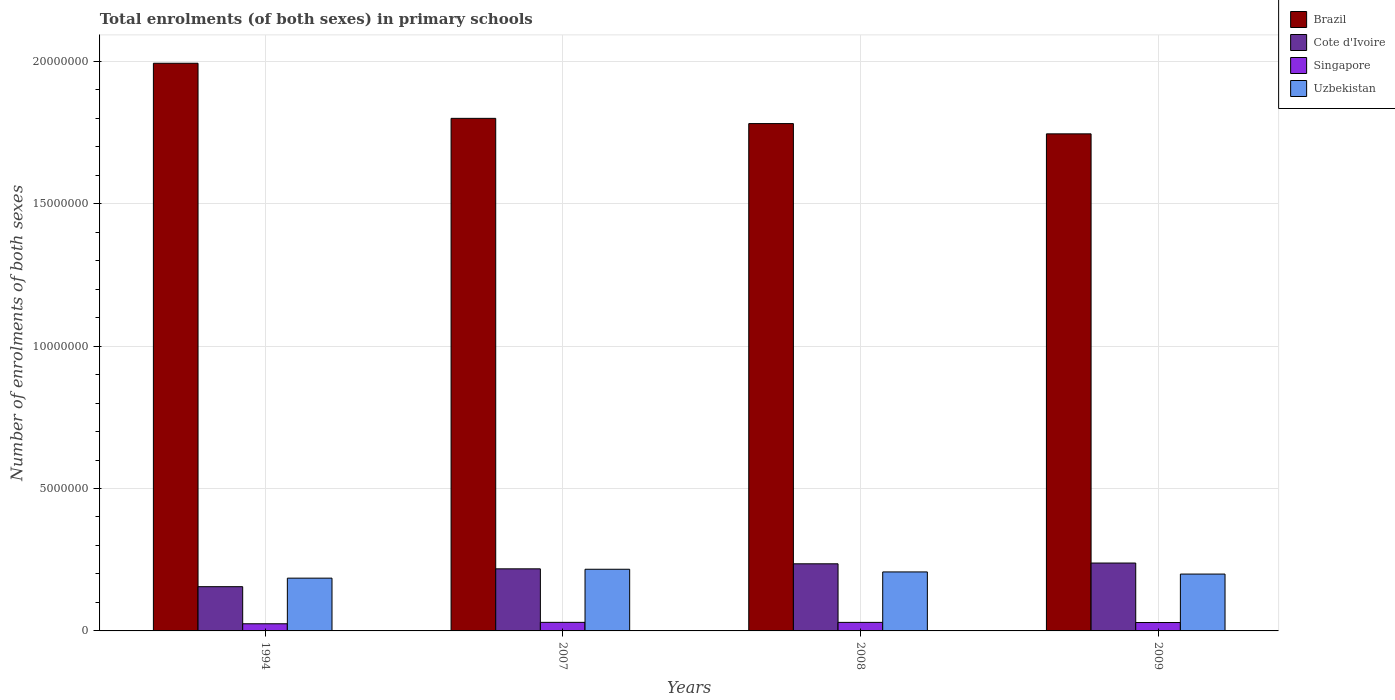How many bars are there on the 3rd tick from the right?
Ensure brevity in your answer.  4. What is the label of the 2nd group of bars from the left?
Your answer should be compact. 2007. What is the number of enrolments in primary schools in Uzbekistan in 1994?
Ensure brevity in your answer.  1.85e+06. Across all years, what is the maximum number of enrolments in primary schools in Uzbekistan?
Provide a short and direct response. 2.16e+06. Across all years, what is the minimum number of enrolments in primary schools in Uzbekistan?
Your answer should be very brief. 1.85e+06. In which year was the number of enrolments in primary schools in Uzbekistan minimum?
Your answer should be very brief. 1994. What is the total number of enrolments in primary schools in Uzbekistan in the graph?
Keep it short and to the point. 8.08e+06. What is the difference between the number of enrolments in primary schools in Cote d'Ivoire in 2008 and that in 2009?
Offer a terse response. -2.71e+04. What is the difference between the number of enrolments in primary schools in Brazil in 2009 and the number of enrolments in primary schools in Singapore in 1994?
Offer a terse response. 1.72e+07. What is the average number of enrolments in primary schools in Cote d'Ivoire per year?
Your response must be concise. 2.12e+06. In the year 2009, what is the difference between the number of enrolments in primary schools in Brazil and number of enrolments in primary schools in Singapore?
Your response must be concise. 1.72e+07. What is the ratio of the number of enrolments in primary schools in Uzbekistan in 2007 to that in 2009?
Your response must be concise. 1.08. What is the difference between the highest and the second highest number of enrolments in primary schools in Singapore?
Keep it short and to the point. 1397. What is the difference between the highest and the lowest number of enrolments in primary schools in Singapore?
Make the answer very short. 5.00e+04. In how many years, is the number of enrolments in primary schools in Cote d'Ivoire greater than the average number of enrolments in primary schools in Cote d'Ivoire taken over all years?
Your answer should be very brief. 3. What does the 2nd bar from the left in 2009 represents?
Give a very brief answer. Cote d'Ivoire. What does the 3rd bar from the right in 2007 represents?
Make the answer very short. Cote d'Ivoire. Are all the bars in the graph horizontal?
Offer a terse response. No. Does the graph contain any zero values?
Your response must be concise. No. What is the title of the graph?
Offer a very short reply. Total enrolments (of both sexes) in primary schools. What is the label or title of the Y-axis?
Give a very brief answer. Number of enrolments of both sexes. What is the Number of enrolments of both sexes in Brazil in 1994?
Give a very brief answer. 1.99e+07. What is the Number of enrolments of both sexes of Cote d'Ivoire in 1994?
Your response must be concise. 1.55e+06. What is the Number of enrolments of both sexes in Singapore in 1994?
Ensure brevity in your answer.  2.51e+05. What is the Number of enrolments of both sexes of Uzbekistan in 1994?
Make the answer very short. 1.85e+06. What is the Number of enrolments of both sexes of Brazil in 2007?
Your response must be concise. 1.80e+07. What is the Number of enrolments of both sexes of Cote d'Ivoire in 2007?
Provide a short and direct response. 2.18e+06. What is the Number of enrolments of both sexes of Singapore in 2007?
Keep it short and to the point. 3.01e+05. What is the Number of enrolments of both sexes in Uzbekistan in 2007?
Provide a succinct answer. 2.16e+06. What is the Number of enrolments of both sexes of Brazil in 2008?
Give a very brief answer. 1.78e+07. What is the Number of enrolments of both sexes of Cote d'Ivoire in 2008?
Your answer should be very brief. 2.36e+06. What is the Number of enrolments of both sexes of Singapore in 2008?
Keep it short and to the point. 3.00e+05. What is the Number of enrolments of both sexes in Uzbekistan in 2008?
Your response must be concise. 2.07e+06. What is the Number of enrolments of both sexes in Brazil in 2009?
Provide a succinct answer. 1.75e+07. What is the Number of enrolments of both sexes of Cote d'Ivoire in 2009?
Provide a short and direct response. 2.38e+06. What is the Number of enrolments of both sexes in Singapore in 2009?
Offer a very short reply. 2.95e+05. What is the Number of enrolments of both sexes of Uzbekistan in 2009?
Keep it short and to the point. 2.00e+06. Across all years, what is the maximum Number of enrolments of both sexes in Brazil?
Offer a terse response. 1.99e+07. Across all years, what is the maximum Number of enrolments of both sexes in Cote d'Ivoire?
Provide a succinct answer. 2.38e+06. Across all years, what is the maximum Number of enrolments of both sexes in Singapore?
Offer a very short reply. 3.01e+05. Across all years, what is the maximum Number of enrolments of both sexes of Uzbekistan?
Offer a terse response. 2.16e+06. Across all years, what is the minimum Number of enrolments of both sexes of Brazil?
Offer a very short reply. 1.75e+07. Across all years, what is the minimum Number of enrolments of both sexes of Cote d'Ivoire?
Provide a short and direct response. 1.55e+06. Across all years, what is the minimum Number of enrolments of both sexes of Singapore?
Keep it short and to the point. 2.51e+05. Across all years, what is the minimum Number of enrolments of both sexes in Uzbekistan?
Your response must be concise. 1.85e+06. What is the total Number of enrolments of both sexes in Brazil in the graph?
Offer a very short reply. 7.32e+07. What is the total Number of enrolments of both sexes in Cote d'Ivoire in the graph?
Provide a succinct answer. 8.47e+06. What is the total Number of enrolments of both sexes of Singapore in the graph?
Your answer should be compact. 1.15e+06. What is the total Number of enrolments of both sexes in Uzbekistan in the graph?
Offer a terse response. 8.08e+06. What is the difference between the Number of enrolments of both sexes of Brazil in 1994 and that in 2007?
Your answer should be compact. 1.93e+06. What is the difference between the Number of enrolments of both sexes of Cote d'Ivoire in 1994 and that in 2007?
Offer a very short reply. -6.26e+05. What is the difference between the Number of enrolments of both sexes of Singapore in 1994 and that in 2007?
Provide a succinct answer. -5.00e+04. What is the difference between the Number of enrolments of both sexes in Uzbekistan in 1994 and that in 2007?
Make the answer very short. -3.12e+05. What is the difference between the Number of enrolments of both sexes in Brazil in 1994 and that in 2008?
Your answer should be compact. 2.12e+06. What is the difference between the Number of enrolments of both sexes of Cote d'Ivoire in 1994 and that in 2008?
Offer a terse response. -8.03e+05. What is the difference between the Number of enrolments of both sexes of Singapore in 1994 and that in 2008?
Offer a terse response. -4.86e+04. What is the difference between the Number of enrolments of both sexes in Uzbekistan in 1994 and that in 2008?
Give a very brief answer. -2.18e+05. What is the difference between the Number of enrolments of both sexes in Brazil in 1994 and that in 2009?
Your answer should be very brief. 2.48e+06. What is the difference between the Number of enrolments of both sexes in Cote d'Ivoire in 1994 and that in 2009?
Make the answer very short. -8.30e+05. What is the difference between the Number of enrolments of both sexes of Singapore in 1994 and that in 2009?
Make the answer very short. -4.35e+04. What is the difference between the Number of enrolments of both sexes in Uzbekistan in 1994 and that in 2009?
Give a very brief answer. -1.43e+05. What is the difference between the Number of enrolments of both sexes in Brazil in 2007 and that in 2008?
Make the answer very short. 1.84e+05. What is the difference between the Number of enrolments of both sexes in Cote d'Ivoire in 2007 and that in 2008?
Your answer should be compact. -1.76e+05. What is the difference between the Number of enrolments of both sexes of Singapore in 2007 and that in 2008?
Your response must be concise. 1397. What is the difference between the Number of enrolments of both sexes of Uzbekistan in 2007 and that in 2008?
Offer a terse response. 9.36e+04. What is the difference between the Number of enrolments of both sexes of Brazil in 2007 and that in 2009?
Provide a short and direct response. 5.44e+05. What is the difference between the Number of enrolments of both sexes of Cote d'Ivoire in 2007 and that in 2009?
Make the answer very short. -2.04e+05. What is the difference between the Number of enrolments of both sexes in Singapore in 2007 and that in 2009?
Offer a terse response. 6499. What is the difference between the Number of enrolments of both sexes in Uzbekistan in 2007 and that in 2009?
Your answer should be compact. 1.69e+05. What is the difference between the Number of enrolments of both sexes of Brazil in 2008 and that in 2009?
Your answer should be compact. 3.61e+05. What is the difference between the Number of enrolments of both sexes in Cote d'Ivoire in 2008 and that in 2009?
Your response must be concise. -2.71e+04. What is the difference between the Number of enrolments of both sexes in Singapore in 2008 and that in 2009?
Provide a succinct answer. 5102. What is the difference between the Number of enrolments of both sexes in Uzbekistan in 2008 and that in 2009?
Keep it short and to the point. 7.56e+04. What is the difference between the Number of enrolments of both sexes of Brazil in 1994 and the Number of enrolments of both sexes of Cote d'Ivoire in 2007?
Provide a short and direct response. 1.78e+07. What is the difference between the Number of enrolments of both sexes in Brazil in 1994 and the Number of enrolments of both sexes in Singapore in 2007?
Your answer should be very brief. 1.96e+07. What is the difference between the Number of enrolments of both sexes of Brazil in 1994 and the Number of enrolments of both sexes of Uzbekistan in 2007?
Make the answer very short. 1.78e+07. What is the difference between the Number of enrolments of both sexes of Cote d'Ivoire in 1994 and the Number of enrolments of both sexes of Singapore in 2007?
Your answer should be compact. 1.25e+06. What is the difference between the Number of enrolments of both sexes of Cote d'Ivoire in 1994 and the Number of enrolments of both sexes of Uzbekistan in 2007?
Your answer should be compact. -6.11e+05. What is the difference between the Number of enrolments of both sexes of Singapore in 1994 and the Number of enrolments of both sexes of Uzbekistan in 2007?
Offer a terse response. -1.91e+06. What is the difference between the Number of enrolments of both sexes in Brazil in 1994 and the Number of enrolments of both sexes in Cote d'Ivoire in 2008?
Ensure brevity in your answer.  1.76e+07. What is the difference between the Number of enrolments of both sexes of Brazil in 1994 and the Number of enrolments of both sexes of Singapore in 2008?
Offer a very short reply. 1.96e+07. What is the difference between the Number of enrolments of both sexes in Brazil in 1994 and the Number of enrolments of both sexes in Uzbekistan in 2008?
Offer a terse response. 1.79e+07. What is the difference between the Number of enrolments of both sexes of Cote d'Ivoire in 1994 and the Number of enrolments of both sexes of Singapore in 2008?
Your answer should be compact. 1.25e+06. What is the difference between the Number of enrolments of both sexes of Cote d'Ivoire in 1994 and the Number of enrolments of both sexes of Uzbekistan in 2008?
Keep it short and to the point. -5.18e+05. What is the difference between the Number of enrolments of both sexes in Singapore in 1994 and the Number of enrolments of both sexes in Uzbekistan in 2008?
Give a very brief answer. -1.82e+06. What is the difference between the Number of enrolments of both sexes of Brazil in 1994 and the Number of enrolments of both sexes of Cote d'Ivoire in 2009?
Offer a terse response. 1.75e+07. What is the difference between the Number of enrolments of both sexes in Brazil in 1994 and the Number of enrolments of both sexes in Singapore in 2009?
Offer a very short reply. 1.96e+07. What is the difference between the Number of enrolments of both sexes in Brazil in 1994 and the Number of enrolments of both sexes in Uzbekistan in 2009?
Provide a succinct answer. 1.79e+07. What is the difference between the Number of enrolments of both sexes in Cote d'Ivoire in 1994 and the Number of enrolments of both sexes in Singapore in 2009?
Give a very brief answer. 1.26e+06. What is the difference between the Number of enrolments of both sexes in Cote d'Ivoire in 1994 and the Number of enrolments of both sexes in Uzbekistan in 2009?
Offer a terse response. -4.42e+05. What is the difference between the Number of enrolments of both sexes in Singapore in 1994 and the Number of enrolments of both sexes in Uzbekistan in 2009?
Give a very brief answer. -1.74e+06. What is the difference between the Number of enrolments of both sexes of Brazil in 2007 and the Number of enrolments of both sexes of Cote d'Ivoire in 2008?
Provide a succinct answer. 1.56e+07. What is the difference between the Number of enrolments of both sexes in Brazil in 2007 and the Number of enrolments of both sexes in Singapore in 2008?
Provide a succinct answer. 1.77e+07. What is the difference between the Number of enrolments of both sexes of Brazil in 2007 and the Number of enrolments of both sexes of Uzbekistan in 2008?
Your answer should be compact. 1.59e+07. What is the difference between the Number of enrolments of both sexes in Cote d'Ivoire in 2007 and the Number of enrolments of both sexes in Singapore in 2008?
Your answer should be very brief. 1.88e+06. What is the difference between the Number of enrolments of both sexes of Cote d'Ivoire in 2007 and the Number of enrolments of both sexes of Uzbekistan in 2008?
Provide a succinct answer. 1.08e+05. What is the difference between the Number of enrolments of both sexes in Singapore in 2007 and the Number of enrolments of both sexes in Uzbekistan in 2008?
Keep it short and to the point. -1.77e+06. What is the difference between the Number of enrolments of both sexes of Brazil in 2007 and the Number of enrolments of both sexes of Cote d'Ivoire in 2009?
Offer a very short reply. 1.56e+07. What is the difference between the Number of enrolments of both sexes of Brazil in 2007 and the Number of enrolments of both sexes of Singapore in 2009?
Offer a terse response. 1.77e+07. What is the difference between the Number of enrolments of both sexes of Brazil in 2007 and the Number of enrolments of both sexes of Uzbekistan in 2009?
Give a very brief answer. 1.60e+07. What is the difference between the Number of enrolments of both sexes in Cote d'Ivoire in 2007 and the Number of enrolments of both sexes in Singapore in 2009?
Make the answer very short. 1.89e+06. What is the difference between the Number of enrolments of both sexes in Cote d'Ivoire in 2007 and the Number of enrolments of both sexes in Uzbekistan in 2009?
Give a very brief answer. 1.84e+05. What is the difference between the Number of enrolments of both sexes of Singapore in 2007 and the Number of enrolments of both sexes of Uzbekistan in 2009?
Offer a terse response. -1.69e+06. What is the difference between the Number of enrolments of both sexes in Brazil in 2008 and the Number of enrolments of both sexes in Cote d'Ivoire in 2009?
Offer a terse response. 1.54e+07. What is the difference between the Number of enrolments of both sexes of Brazil in 2008 and the Number of enrolments of both sexes of Singapore in 2009?
Offer a very short reply. 1.75e+07. What is the difference between the Number of enrolments of both sexes of Brazil in 2008 and the Number of enrolments of both sexes of Uzbekistan in 2009?
Provide a succinct answer. 1.58e+07. What is the difference between the Number of enrolments of both sexes of Cote d'Ivoire in 2008 and the Number of enrolments of both sexes of Singapore in 2009?
Your answer should be compact. 2.06e+06. What is the difference between the Number of enrolments of both sexes in Cote d'Ivoire in 2008 and the Number of enrolments of both sexes in Uzbekistan in 2009?
Your response must be concise. 3.60e+05. What is the difference between the Number of enrolments of both sexes of Singapore in 2008 and the Number of enrolments of both sexes of Uzbekistan in 2009?
Provide a succinct answer. -1.70e+06. What is the average Number of enrolments of both sexes of Brazil per year?
Make the answer very short. 1.83e+07. What is the average Number of enrolments of both sexes in Cote d'Ivoire per year?
Provide a short and direct response. 2.12e+06. What is the average Number of enrolments of both sexes in Singapore per year?
Give a very brief answer. 2.87e+05. What is the average Number of enrolments of both sexes in Uzbekistan per year?
Your answer should be compact. 2.02e+06. In the year 1994, what is the difference between the Number of enrolments of both sexes in Brazil and Number of enrolments of both sexes in Cote d'Ivoire?
Your response must be concise. 1.84e+07. In the year 1994, what is the difference between the Number of enrolments of both sexes in Brazil and Number of enrolments of both sexes in Singapore?
Provide a short and direct response. 1.97e+07. In the year 1994, what is the difference between the Number of enrolments of both sexes of Brazil and Number of enrolments of both sexes of Uzbekistan?
Your answer should be very brief. 1.81e+07. In the year 1994, what is the difference between the Number of enrolments of both sexes of Cote d'Ivoire and Number of enrolments of both sexes of Singapore?
Offer a very short reply. 1.30e+06. In the year 1994, what is the difference between the Number of enrolments of both sexes in Cote d'Ivoire and Number of enrolments of both sexes in Uzbekistan?
Your response must be concise. -2.99e+05. In the year 1994, what is the difference between the Number of enrolments of both sexes in Singapore and Number of enrolments of both sexes in Uzbekistan?
Keep it short and to the point. -1.60e+06. In the year 2007, what is the difference between the Number of enrolments of both sexes in Brazil and Number of enrolments of both sexes in Cote d'Ivoire?
Offer a very short reply. 1.58e+07. In the year 2007, what is the difference between the Number of enrolments of both sexes in Brazil and Number of enrolments of both sexes in Singapore?
Ensure brevity in your answer.  1.77e+07. In the year 2007, what is the difference between the Number of enrolments of both sexes of Brazil and Number of enrolments of both sexes of Uzbekistan?
Offer a terse response. 1.58e+07. In the year 2007, what is the difference between the Number of enrolments of both sexes of Cote d'Ivoire and Number of enrolments of both sexes of Singapore?
Provide a succinct answer. 1.88e+06. In the year 2007, what is the difference between the Number of enrolments of both sexes in Cote d'Ivoire and Number of enrolments of both sexes in Uzbekistan?
Your response must be concise. 1.49e+04. In the year 2007, what is the difference between the Number of enrolments of both sexes of Singapore and Number of enrolments of both sexes of Uzbekistan?
Keep it short and to the point. -1.86e+06. In the year 2008, what is the difference between the Number of enrolments of both sexes in Brazil and Number of enrolments of both sexes in Cote d'Ivoire?
Make the answer very short. 1.55e+07. In the year 2008, what is the difference between the Number of enrolments of both sexes of Brazil and Number of enrolments of both sexes of Singapore?
Your answer should be very brief. 1.75e+07. In the year 2008, what is the difference between the Number of enrolments of both sexes in Brazil and Number of enrolments of both sexes in Uzbekistan?
Your answer should be very brief. 1.57e+07. In the year 2008, what is the difference between the Number of enrolments of both sexes of Cote d'Ivoire and Number of enrolments of both sexes of Singapore?
Provide a succinct answer. 2.06e+06. In the year 2008, what is the difference between the Number of enrolments of both sexes in Cote d'Ivoire and Number of enrolments of both sexes in Uzbekistan?
Keep it short and to the point. 2.85e+05. In the year 2008, what is the difference between the Number of enrolments of both sexes in Singapore and Number of enrolments of both sexes in Uzbekistan?
Keep it short and to the point. -1.77e+06. In the year 2009, what is the difference between the Number of enrolments of both sexes in Brazil and Number of enrolments of both sexes in Cote d'Ivoire?
Ensure brevity in your answer.  1.51e+07. In the year 2009, what is the difference between the Number of enrolments of both sexes of Brazil and Number of enrolments of both sexes of Singapore?
Give a very brief answer. 1.72e+07. In the year 2009, what is the difference between the Number of enrolments of both sexes of Brazil and Number of enrolments of both sexes of Uzbekistan?
Keep it short and to the point. 1.55e+07. In the year 2009, what is the difference between the Number of enrolments of both sexes of Cote d'Ivoire and Number of enrolments of both sexes of Singapore?
Give a very brief answer. 2.09e+06. In the year 2009, what is the difference between the Number of enrolments of both sexes of Cote d'Ivoire and Number of enrolments of both sexes of Uzbekistan?
Ensure brevity in your answer.  3.88e+05. In the year 2009, what is the difference between the Number of enrolments of both sexes of Singapore and Number of enrolments of both sexes of Uzbekistan?
Offer a very short reply. -1.70e+06. What is the ratio of the Number of enrolments of both sexes of Brazil in 1994 to that in 2007?
Your answer should be compact. 1.11. What is the ratio of the Number of enrolments of both sexes in Cote d'Ivoire in 1994 to that in 2007?
Offer a terse response. 0.71. What is the ratio of the Number of enrolments of both sexes of Singapore in 1994 to that in 2007?
Your answer should be very brief. 0.83. What is the ratio of the Number of enrolments of both sexes in Uzbekistan in 1994 to that in 2007?
Your answer should be compact. 0.86. What is the ratio of the Number of enrolments of both sexes of Brazil in 1994 to that in 2008?
Your answer should be compact. 1.12. What is the ratio of the Number of enrolments of both sexes in Cote d'Ivoire in 1994 to that in 2008?
Your answer should be compact. 0.66. What is the ratio of the Number of enrolments of both sexes in Singapore in 1994 to that in 2008?
Your response must be concise. 0.84. What is the ratio of the Number of enrolments of both sexes of Uzbekistan in 1994 to that in 2008?
Provide a short and direct response. 0.89. What is the ratio of the Number of enrolments of both sexes of Brazil in 1994 to that in 2009?
Provide a short and direct response. 1.14. What is the ratio of the Number of enrolments of both sexes in Cote d'Ivoire in 1994 to that in 2009?
Give a very brief answer. 0.65. What is the ratio of the Number of enrolments of both sexes of Singapore in 1994 to that in 2009?
Offer a terse response. 0.85. What is the ratio of the Number of enrolments of both sexes in Uzbekistan in 1994 to that in 2009?
Keep it short and to the point. 0.93. What is the ratio of the Number of enrolments of both sexes in Brazil in 2007 to that in 2008?
Make the answer very short. 1.01. What is the ratio of the Number of enrolments of both sexes of Cote d'Ivoire in 2007 to that in 2008?
Keep it short and to the point. 0.93. What is the ratio of the Number of enrolments of both sexes of Singapore in 2007 to that in 2008?
Give a very brief answer. 1. What is the ratio of the Number of enrolments of both sexes in Uzbekistan in 2007 to that in 2008?
Your answer should be very brief. 1.05. What is the ratio of the Number of enrolments of both sexes in Brazil in 2007 to that in 2009?
Offer a very short reply. 1.03. What is the ratio of the Number of enrolments of both sexes of Cote d'Ivoire in 2007 to that in 2009?
Make the answer very short. 0.91. What is the ratio of the Number of enrolments of both sexes in Singapore in 2007 to that in 2009?
Keep it short and to the point. 1.02. What is the ratio of the Number of enrolments of both sexes of Uzbekistan in 2007 to that in 2009?
Make the answer very short. 1.08. What is the ratio of the Number of enrolments of both sexes of Brazil in 2008 to that in 2009?
Your answer should be very brief. 1.02. What is the ratio of the Number of enrolments of both sexes of Cote d'Ivoire in 2008 to that in 2009?
Your response must be concise. 0.99. What is the ratio of the Number of enrolments of both sexes of Singapore in 2008 to that in 2009?
Keep it short and to the point. 1.02. What is the ratio of the Number of enrolments of both sexes in Uzbekistan in 2008 to that in 2009?
Your answer should be very brief. 1.04. What is the difference between the highest and the second highest Number of enrolments of both sexes of Brazil?
Provide a succinct answer. 1.93e+06. What is the difference between the highest and the second highest Number of enrolments of both sexes of Cote d'Ivoire?
Provide a short and direct response. 2.71e+04. What is the difference between the highest and the second highest Number of enrolments of both sexes of Singapore?
Provide a succinct answer. 1397. What is the difference between the highest and the second highest Number of enrolments of both sexes of Uzbekistan?
Offer a terse response. 9.36e+04. What is the difference between the highest and the lowest Number of enrolments of both sexes in Brazil?
Provide a short and direct response. 2.48e+06. What is the difference between the highest and the lowest Number of enrolments of both sexes of Cote d'Ivoire?
Keep it short and to the point. 8.30e+05. What is the difference between the highest and the lowest Number of enrolments of both sexes in Singapore?
Offer a very short reply. 5.00e+04. What is the difference between the highest and the lowest Number of enrolments of both sexes of Uzbekistan?
Offer a terse response. 3.12e+05. 